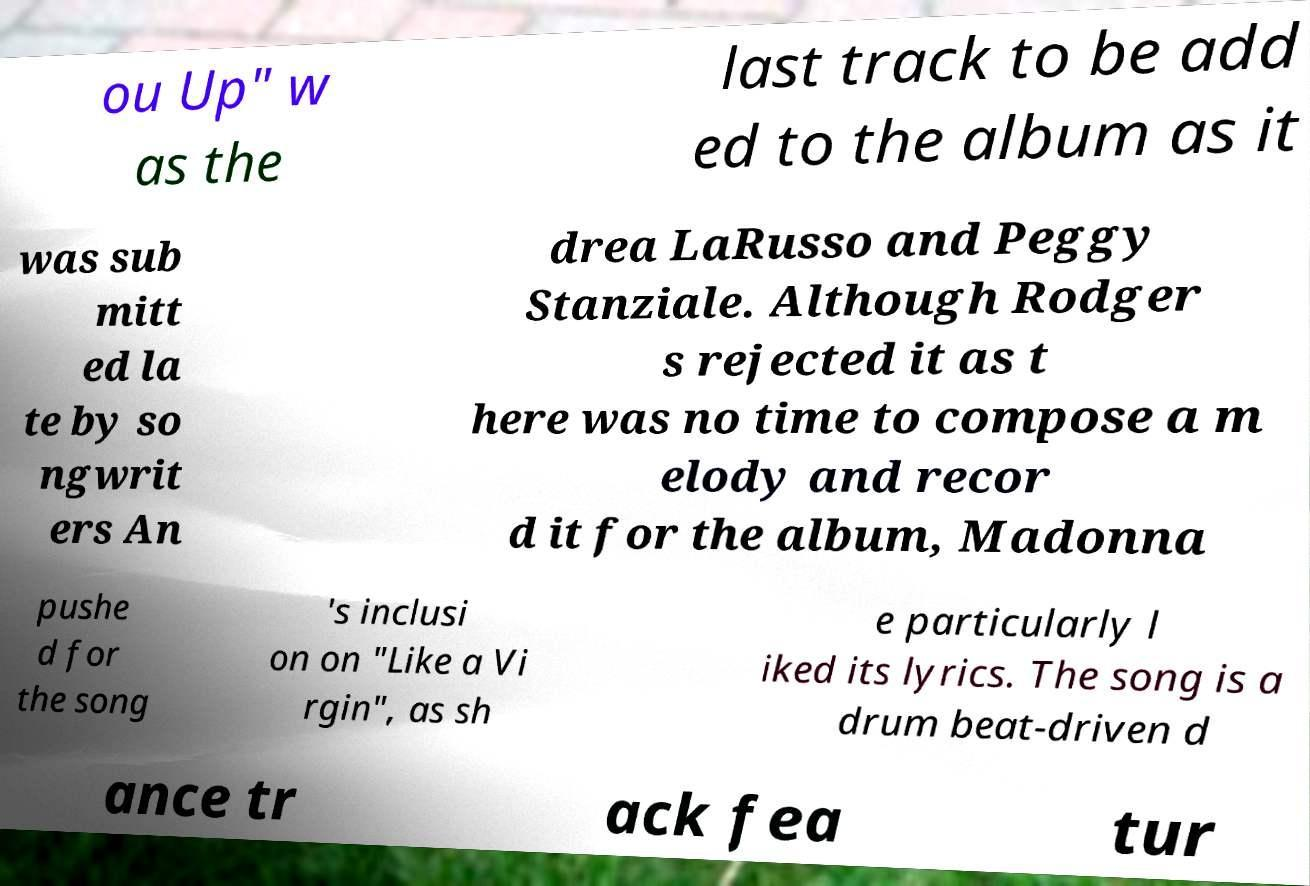Could you assist in decoding the text presented in this image and type it out clearly? ou Up" w as the last track to be add ed to the album as it was sub mitt ed la te by so ngwrit ers An drea LaRusso and Peggy Stanziale. Although Rodger s rejected it as t here was no time to compose a m elody and recor d it for the album, Madonna pushe d for the song 's inclusi on on "Like a Vi rgin", as sh e particularly l iked its lyrics. The song is a drum beat-driven d ance tr ack fea tur 